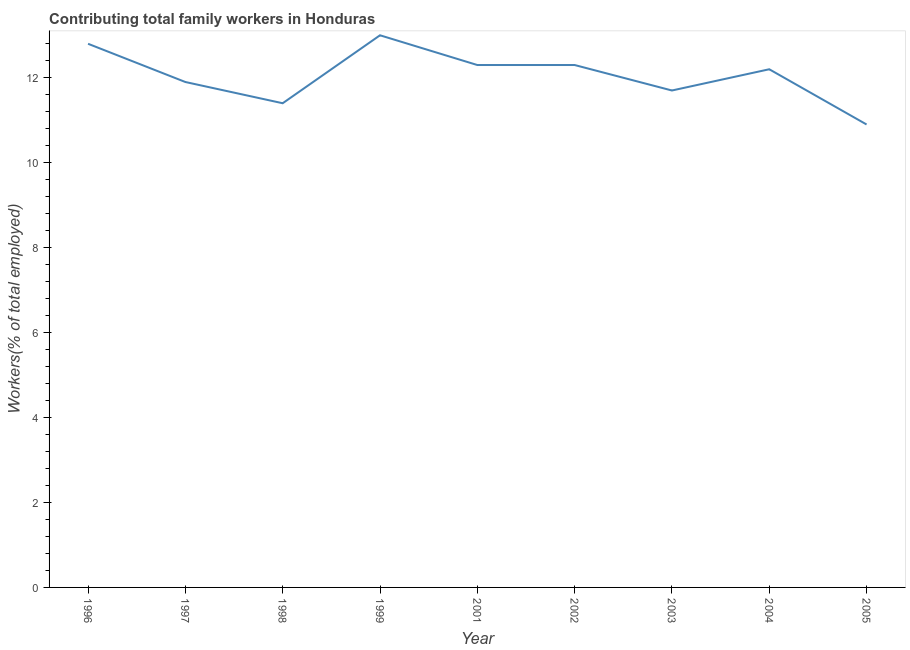What is the contributing family workers in 2003?
Keep it short and to the point. 11.7. Across all years, what is the maximum contributing family workers?
Keep it short and to the point. 13. Across all years, what is the minimum contributing family workers?
Your response must be concise. 10.9. In which year was the contributing family workers maximum?
Provide a short and direct response. 1999. What is the sum of the contributing family workers?
Keep it short and to the point. 108.5. What is the difference between the contributing family workers in 1998 and 2004?
Provide a short and direct response. -0.8. What is the average contributing family workers per year?
Make the answer very short. 12.06. What is the median contributing family workers?
Your answer should be very brief. 12.2. Do a majority of the years between 1996 and 1997 (inclusive) have contributing family workers greater than 9.2 %?
Ensure brevity in your answer.  Yes. What is the ratio of the contributing family workers in 1999 to that in 2005?
Your answer should be very brief. 1.19. Is the contributing family workers in 1996 less than that in 2002?
Your answer should be compact. No. Is the difference between the contributing family workers in 1996 and 2005 greater than the difference between any two years?
Keep it short and to the point. No. What is the difference between the highest and the second highest contributing family workers?
Offer a very short reply. 0.2. Is the sum of the contributing family workers in 1999 and 2003 greater than the maximum contributing family workers across all years?
Provide a short and direct response. Yes. What is the difference between the highest and the lowest contributing family workers?
Provide a short and direct response. 2.1. In how many years, is the contributing family workers greater than the average contributing family workers taken over all years?
Provide a succinct answer. 5. How many lines are there?
Offer a very short reply. 1. Does the graph contain grids?
Make the answer very short. No. What is the title of the graph?
Offer a very short reply. Contributing total family workers in Honduras. What is the label or title of the X-axis?
Offer a terse response. Year. What is the label or title of the Y-axis?
Offer a terse response. Workers(% of total employed). What is the Workers(% of total employed) in 1996?
Your response must be concise. 12.8. What is the Workers(% of total employed) in 1997?
Give a very brief answer. 11.9. What is the Workers(% of total employed) of 1998?
Offer a terse response. 11.4. What is the Workers(% of total employed) in 2001?
Your answer should be compact. 12.3. What is the Workers(% of total employed) in 2002?
Ensure brevity in your answer.  12.3. What is the Workers(% of total employed) in 2003?
Your response must be concise. 11.7. What is the Workers(% of total employed) of 2004?
Your answer should be compact. 12.2. What is the Workers(% of total employed) of 2005?
Give a very brief answer. 10.9. What is the difference between the Workers(% of total employed) in 1996 and 1997?
Give a very brief answer. 0.9. What is the difference between the Workers(% of total employed) in 1996 and 1998?
Provide a succinct answer. 1.4. What is the difference between the Workers(% of total employed) in 1996 and 1999?
Offer a terse response. -0.2. What is the difference between the Workers(% of total employed) in 1996 and 2004?
Give a very brief answer. 0.6. What is the difference between the Workers(% of total employed) in 1997 and 1999?
Keep it short and to the point. -1.1. What is the difference between the Workers(% of total employed) in 1997 and 2001?
Provide a succinct answer. -0.4. What is the difference between the Workers(% of total employed) in 1997 and 2002?
Your answer should be very brief. -0.4. What is the difference between the Workers(% of total employed) in 1997 and 2003?
Your answer should be compact. 0.2. What is the difference between the Workers(% of total employed) in 1997 and 2004?
Keep it short and to the point. -0.3. What is the difference between the Workers(% of total employed) in 1997 and 2005?
Your answer should be very brief. 1. What is the difference between the Workers(% of total employed) in 1998 and 2001?
Keep it short and to the point. -0.9. What is the difference between the Workers(% of total employed) in 1998 and 2002?
Keep it short and to the point. -0.9. What is the difference between the Workers(% of total employed) in 1998 and 2003?
Keep it short and to the point. -0.3. What is the difference between the Workers(% of total employed) in 1999 and 2001?
Keep it short and to the point. 0.7. What is the difference between the Workers(% of total employed) in 1999 and 2002?
Offer a terse response. 0.7. What is the difference between the Workers(% of total employed) in 2001 and 2003?
Your answer should be compact. 0.6. What is the difference between the Workers(% of total employed) in 2002 and 2003?
Ensure brevity in your answer.  0.6. What is the difference between the Workers(% of total employed) in 2002 and 2004?
Offer a terse response. 0.1. What is the difference between the Workers(% of total employed) in 2003 and 2005?
Your response must be concise. 0.8. What is the ratio of the Workers(% of total employed) in 1996 to that in 1997?
Offer a very short reply. 1.08. What is the ratio of the Workers(% of total employed) in 1996 to that in 1998?
Provide a succinct answer. 1.12. What is the ratio of the Workers(% of total employed) in 1996 to that in 2001?
Make the answer very short. 1.04. What is the ratio of the Workers(% of total employed) in 1996 to that in 2002?
Your answer should be compact. 1.04. What is the ratio of the Workers(% of total employed) in 1996 to that in 2003?
Your answer should be very brief. 1.09. What is the ratio of the Workers(% of total employed) in 1996 to that in 2004?
Your answer should be very brief. 1.05. What is the ratio of the Workers(% of total employed) in 1996 to that in 2005?
Provide a succinct answer. 1.17. What is the ratio of the Workers(% of total employed) in 1997 to that in 1998?
Offer a very short reply. 1.04. What is the ratio of the Workers(% of total employed) in 1997 to that in 1999?
Provide a short and direct response. 0.92. What is the ratio of the Workers(% of total employed) in 1997 to that in 2005?
Make the answer very short. 1.09. What is the ratio of the Workers(% of total employed) in 1998 to that in 1999?
Provide a succinct answer. 0.88. What is the ratio of the Workers(% of total employed) in 1998 to that in 2001?
Keep it short and to the point. 0.93. What is the ratio of the Workers(% of total employed) in 1998 to that in 2002?
Ensure brevity in your answer.  0.93. What is the ratio of the Workers(% of total employed) in 1998 to that in 2004?
Ensure brevity in your answer.  0.93. What is the ratio of the Workers(% of total employed) in 1998 to that in 2005?
Offer a very short reply. 1.05. What is the ratio of the Workers(% of total employed) in 1999 to that in 2001?
Keep it short and to the point. 1.06. What is the ratio of the Workers(% of total employed) in 1999 to that in 2002?
Offer a very short reply. 1.06. What is the ratio of the Workers(% of total employed) in 1999 to that in 2003?
Your response must be concise. 1.11. What is the ratio of the Workers(% of total employed) in 1999 to that in 2004?
Provide a succinct answer. 1.07. What is the ratio of the Workers(% of total employed) in 1999 to that in 2005?
Ensure brevity in your answer.  1.19. What is the ratio of the Workers(% of total employed) in 2001 to that in 2003?
Your response must be concise. 1.05. What is the ratio of the Workers(% of total employed) in 2001 to that in 2004?
Keep it short and to the point. 1.01. What is the ratio of the Workers(% of total employed) in 2001 to that in 2005?
Your answer should be very brief. 1.13. What is the ratio of the Workers(% of total employed) in 2002 to that in 2003?
Your response must be concise. 1.05. What is the ratio of the Workers(% of total employed) in 2002 to that in 2005?
Offer a terse response. 1.13. What is the ratio of the Workers(% of total employed) in 2003 to that in 2004?
Provide a short and direct response. 0.96. What is the ratio of the Workers(% of total employed) in 2003 to that in 2005?
Your response must be concise. 1.07. What is the ratio of the Workers(% of total employed) in 2004 to that in 2005?
Your response must be concise. 1.12. 